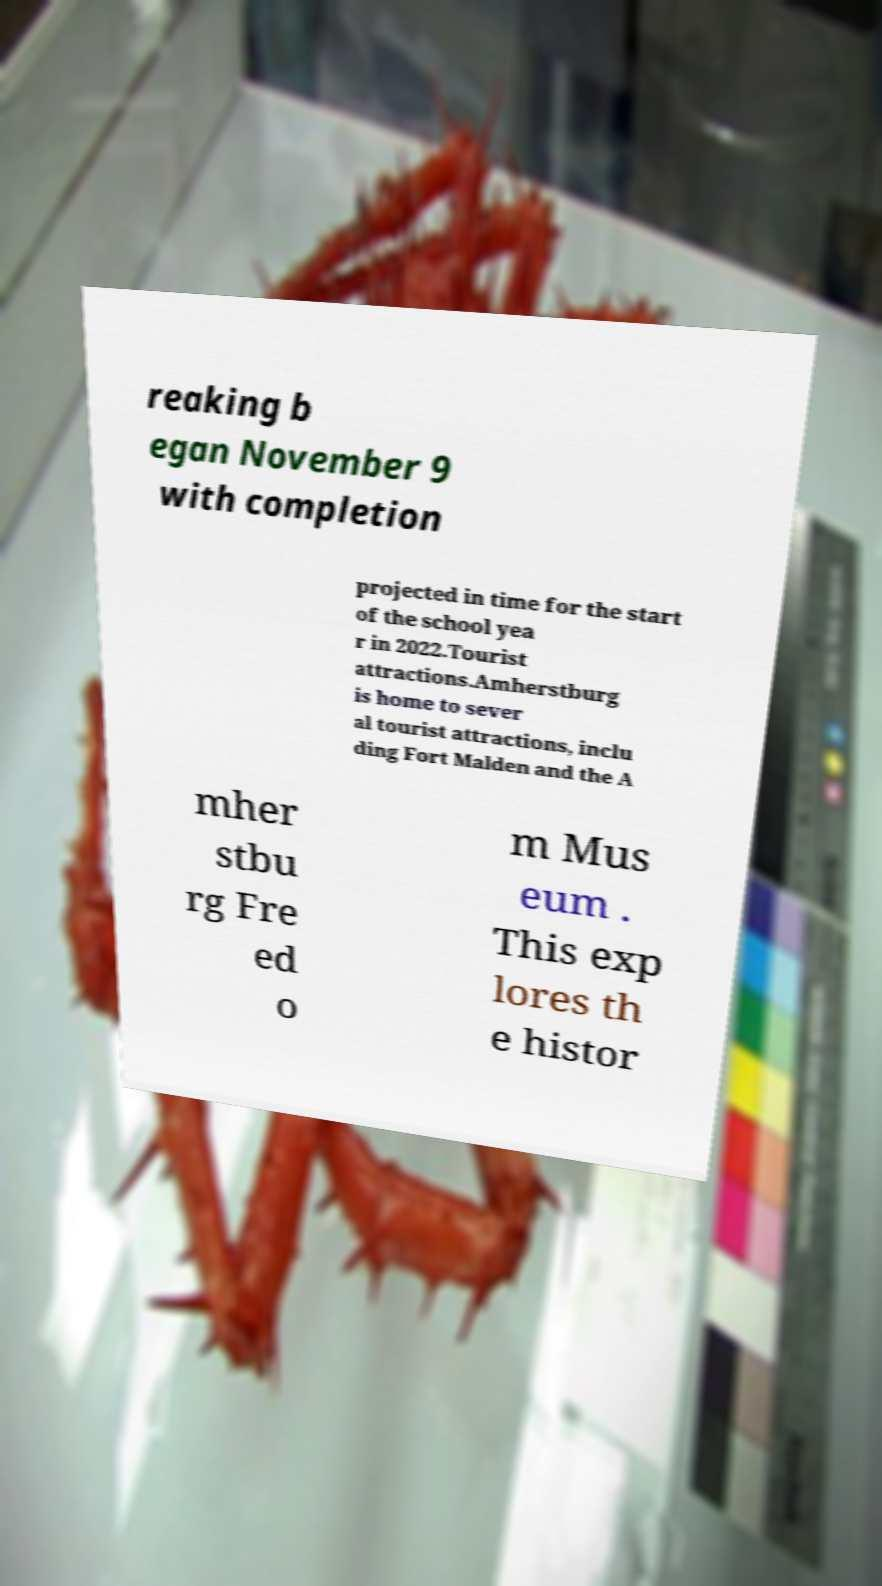Could you extract and type out the text from this image? reaking b egan November 9 with completion projected in time for the start of the school yea r in 2022.Tourist attractions.Amherstburg is home to sever al tourist attractions, inclu ding Fort Malden and the A mher stbu rg Fre ed o m Mus eum . This exp lores th e histor 